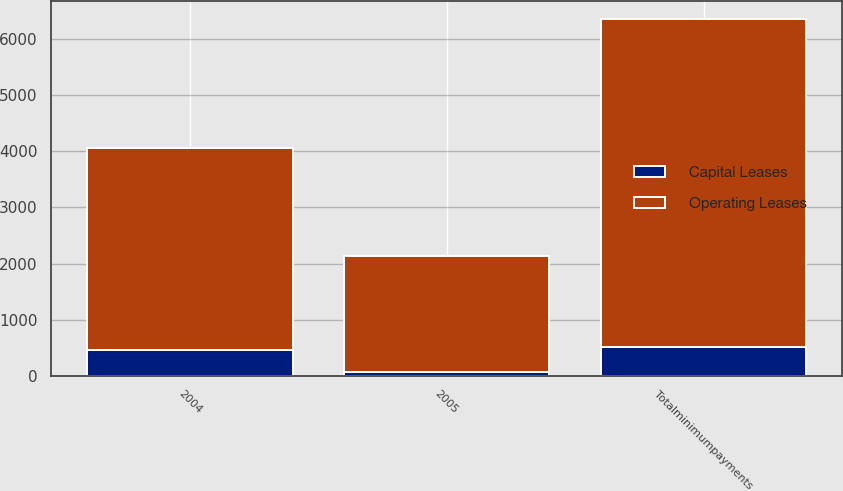<chart> <loc_0><loc_0><loc_500><loc_500><stacked_bar_chart><ecel><fcel>2004<fcel>2005<fcel>Totalminimumpayments<nl><fcel>Capital Leases<fcel>462<fcel>55<fcel>517<nl><fcel>Operating Leases<fcel>3592<fcel>2076<fcel>5843<nl></chart> 